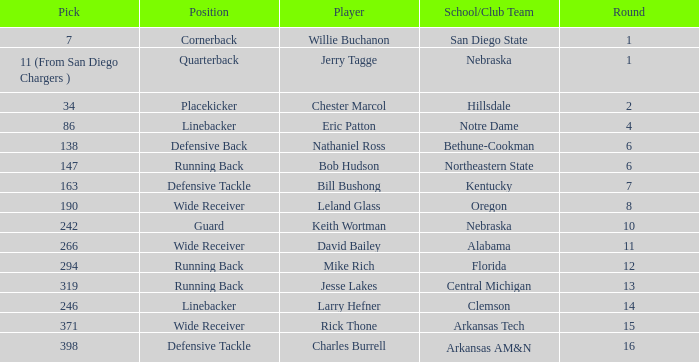Which pick has a school/club team that is kentucky? 163.0. Give me the full table as a dictionary. {'header': ['Pick', 'Position', 'Player', 'School/Club Team', 'Round'], 'rows': [['7', 'Cornerback', 'Willie Buchanon', 'San Diego State', '1'], ['11 (From San Diego Chargers )', 'Quarterback', 'Jerry Tagge', 'Nebraska', '1'], ['34', 'Placekicker', 'Chester Marcol', 'Hillsdale', '2'], ['86', 'Linebacker', 'Eric Patton', 'Notre Dame', '4'], ['138', 'Defensive Back', 'Nathaniel Ross', 'Bethune-Cookman', '6'], ['147', 'Running Back', 'Bob Hudson', 'Northeastern State', '6'], ['163', 'Defensive Tackle', 'Bill Bushong', 'Kentucky', '7'], ['190', 'Wide Receiver', 'Leland Glass', 'Oregon', '8'], ['242', 'Guard', 'Keith Wortman', 'Nebraska', '10'], ['266', 'Wide Receiver', 'David Bailey', 'Alabama', '11'], ['294', 'Running Back', 'Mike Rich', 'Florida', '12'], ['319', 'Running Back', 'Jesse Lakes', 'Central Michigan', '13'], ['246', 'Linebacker', 'Larry Hefner', 'Clemson', '14'], ['371', 'Wide Receiver', 'Rick Thone', 'Arkansas Tech', '15'], ['398', 'Defensive Tackle', 'Charles Burrell', 'Arkansas AM&N', '16']]} 